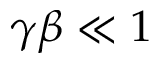<formula> <loc_0><loc_0><loc_500><loc_500>\gamma \beta \ll 1</formula> 